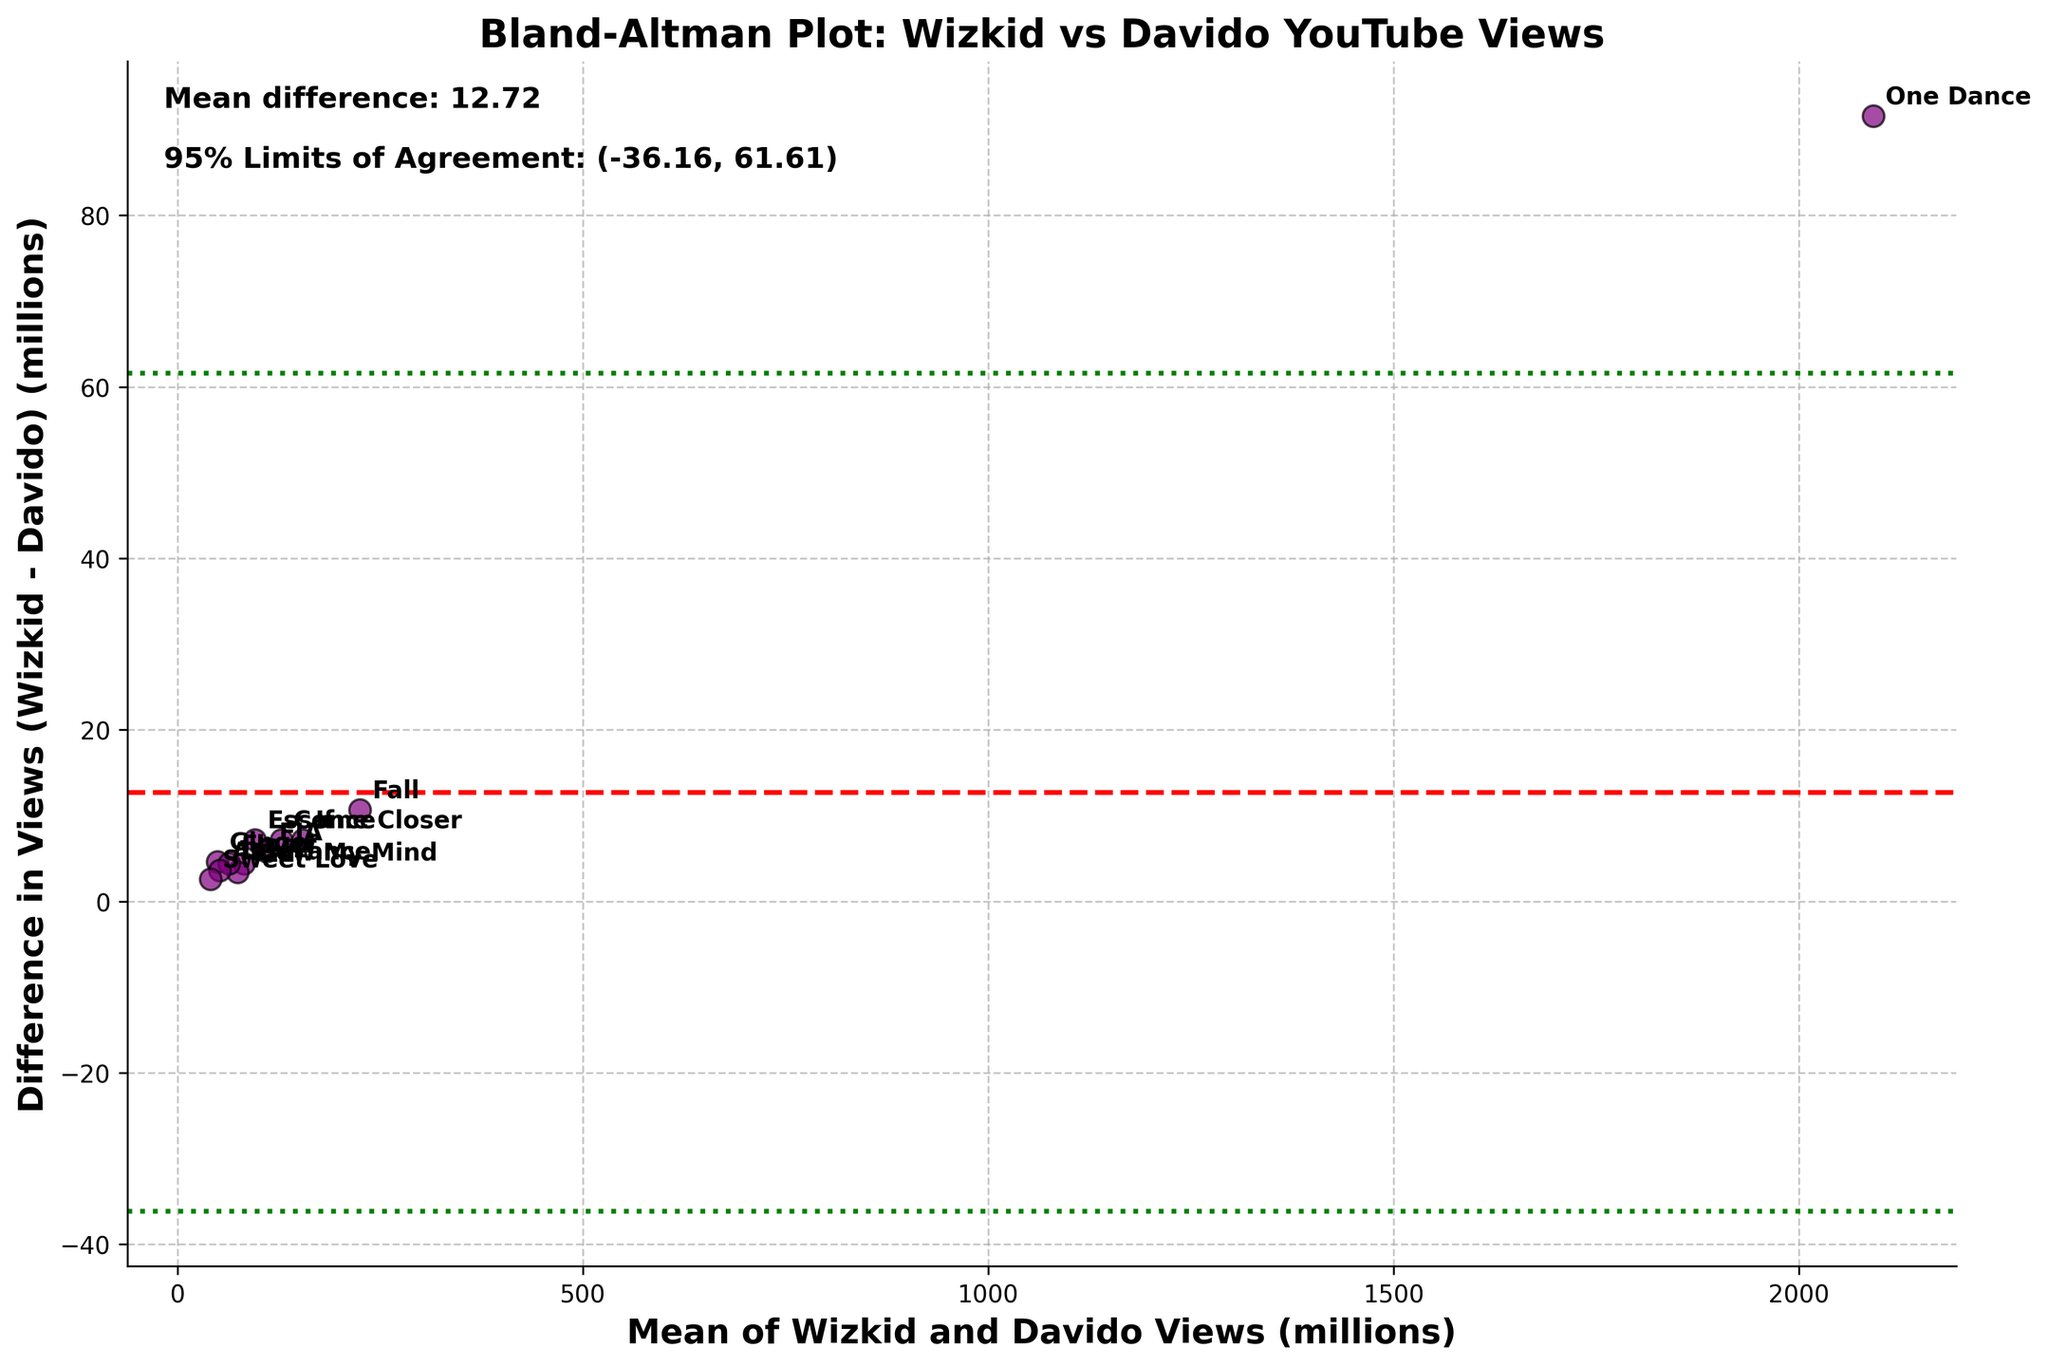How many data points are in the plot? By counting the number of distinct points shown in the scatter plot along with the annotations for each song title, we see there are 12 data points.
Answer: 12 What is the mean difference in views between Wizkid and Davido? The mean difference between Wizkid and Davido views is shown by the horizontal red dashed line, with the exact value provided in the text on the plot, which is around 6.83 million views.
Answer: 6.83 million What is the title of the plot? The title of the plot, which is displayed at the top center of the figure in bold font, is 'Bland-Altman Plot: Wizkid vs Davido YouTube Views'.
Answer: Bland-Altman Plot: Wizkid vs Davido YouTube Views What are the 95% limits of agreement for the differences in views? The 95% limits of agreement are marked by the green dashed lines on the plot. The values are also indicated in the text, showing a range from -35.31 to 49 million views.
Answer: (-35.31, 49) Which song has the highest mean views, and what is that value? By identifying the point farthest along the x-axis and considering the known views of the songs, 'One Dance' has the highest mean views, with (2137.2 + 2045.6)/2 = 2091.4 million views.
Answer: One Dance, 2091.4 million What is the difference in views between Wizkid and Davido for the song 'Fall'? By locating the annotation for 'Fall' and evaluating its y-coordinate relative to the labeled axis values, the difference in views is approximately 10.7 million (230.5 - 219.8).
Answer: 10.7 million What is the discrepancy in views between the songs with the smallest and the largest difference? By comparing the points with the smallest difference ('Assurance', difference ≈ 3.6 million) and the largest difference ('One Dance', difference ≈ 91.6 million), the discrepancy is about 88 million.
Answer: 88 million Which songs lie within the 95% limits of agreement? By checking which annotated points fall between the two green dashed lines, all songs lie within the 95% limits of agreement, indicating overall agreement between Wizkid and Davido's views.
Answer: All songs For the song 'Essence', how does Wizkid's view count compare to Davido's view count? By finding the annotation for 'Essence' and examining its y-coordinate, Wizkid's views are slightly higher than Davido's views, around a difference of 7.2 million (99.5 - 92.3).
Answer: Higher by 7.2 million 